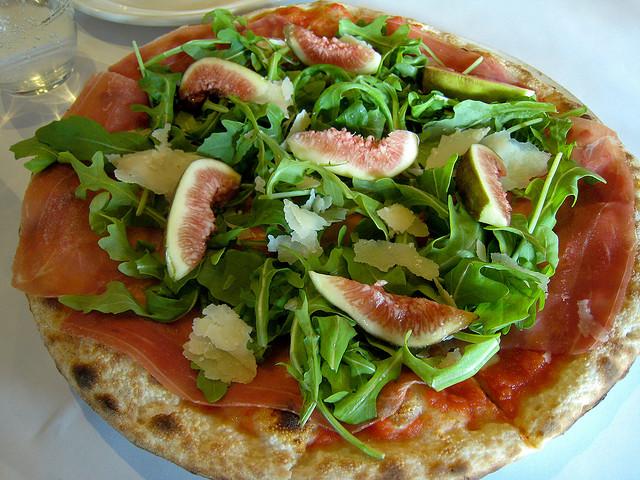What fruit is on top of this pizza?
Keep it brief. Yes. Does this pizza have cheese?
Give a very brief answer. No. What is brown spot?
Keep it brief. Burn. 